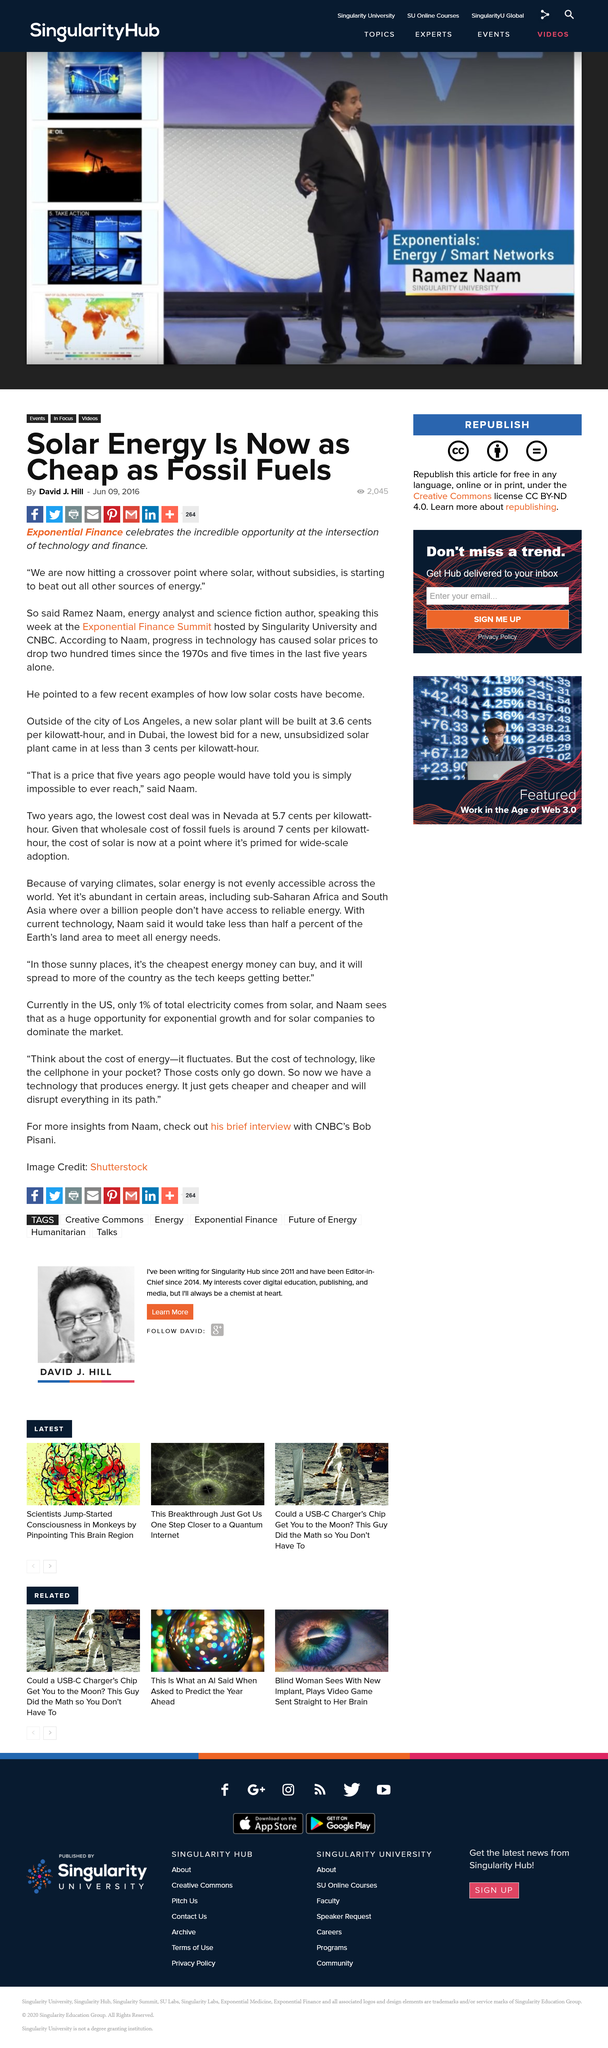Draw attention to some important aspects in this diagram. A new solar power plant is being built outside of Los Angeles, and it will cost 3.6 cents per kilowatt-hour to generate electricity. Ramez Naam, an energy analyst and science fiction author, has recently given examples of how low the costs of solar energy have become. Solar energy is now as cheap as fossil fuels, making it a viable and cost-effective alternative to traditional sources of energy. 